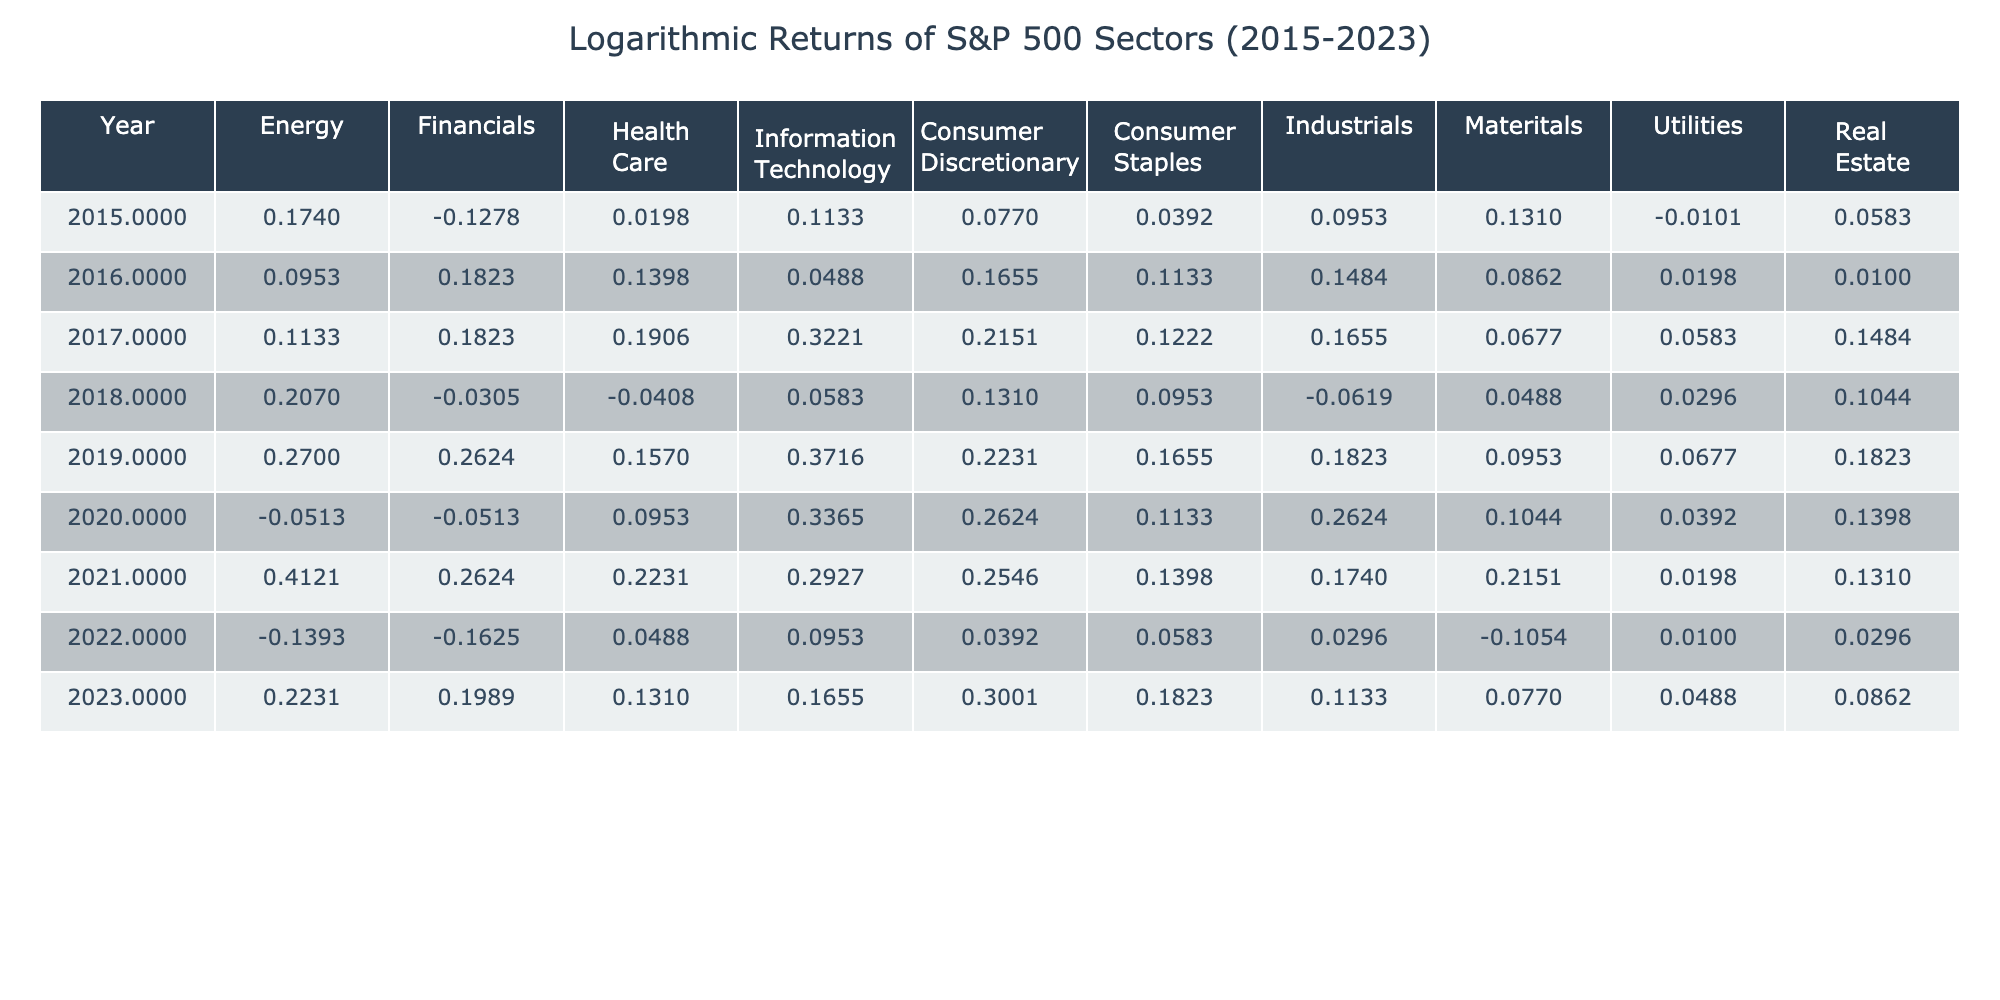What was the logarithmic return of the Energy sector in 2019? In 2019, the logarithmic return for the Energy sector is listed in the table. Referring to that specific row, the value is 0.31.
Answer: 0.31 What was the highest logarithmic return recorded in the Information Technology sector? To find the highest return in the Information Technology sector, I look through all the values in that column. The highest return is 0.45, which occurred in 2019.
Answer: 0.45 Was there a negative logarithmic return in the Consumer Discretionary sector in 2022? Checking the table for the Consumer Discretionary sector in 2022, I see the value is 0.04, which is not negative. Therefore, the statement is false.
Answer: No What is the average logarithmic return of the Health Care sector over the years from 2015 to 2023? To calculate the average for the Health Care sector, I sum the returns over the specified years: 0.02 + 0.15 + 0.21 - 0.04 + 0.17 + 0.10 + 0.25 + 0.05 + 0.14 = 0.90. Then, divide by 9 years (0.90/9) gives an average of 0.10.
Answer: 0.10 Which sector showed the most consistent performance (i.e., least variation) over the years? I analyze the returns for all sectors by looking at the maximum and minimum values per sector. For example, the Financials sector has values ranging from -0.15 to 0.30, while the Utilities sector ranges from -0.01 to 0.07. The sector that shows the smallest range is the Utilities sector, indicating consistent performance.
Answer: Utilities What was the difference in logarithmic return between the Energy and Consumer Staples sectors in 2021? For 2021, the return in the Energy sector is 0.51, and for Consumer Staples, it is 0.15. The difference is calculated as 0.51 - 0.15 = 0.36.
Answer: 0.36 Did the Health Care sector return a higher logarithmic value than the Utilities sector in 2018? Comparing the Health Care sector's value of -0.04 and the Utilities sector's value of 0.03 in 2018, it is clear that -0.04 is less than 0.03, meaning the statement is false.
Answer: No What are the logarithmic returns of the Consumer Staples sector in 2016 and 2020, and what is their combined total? The returns for Consumer Staples are 0.12 for 2016 and 0.12 for 2020. Their combined total is calculated as 0.12 + 0.12 = 0.24.
Answer: 0.24 